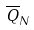<formula> <loc_0><loc_0><loc_500><loc_500>\overline { Q } _ { N }</formula> 